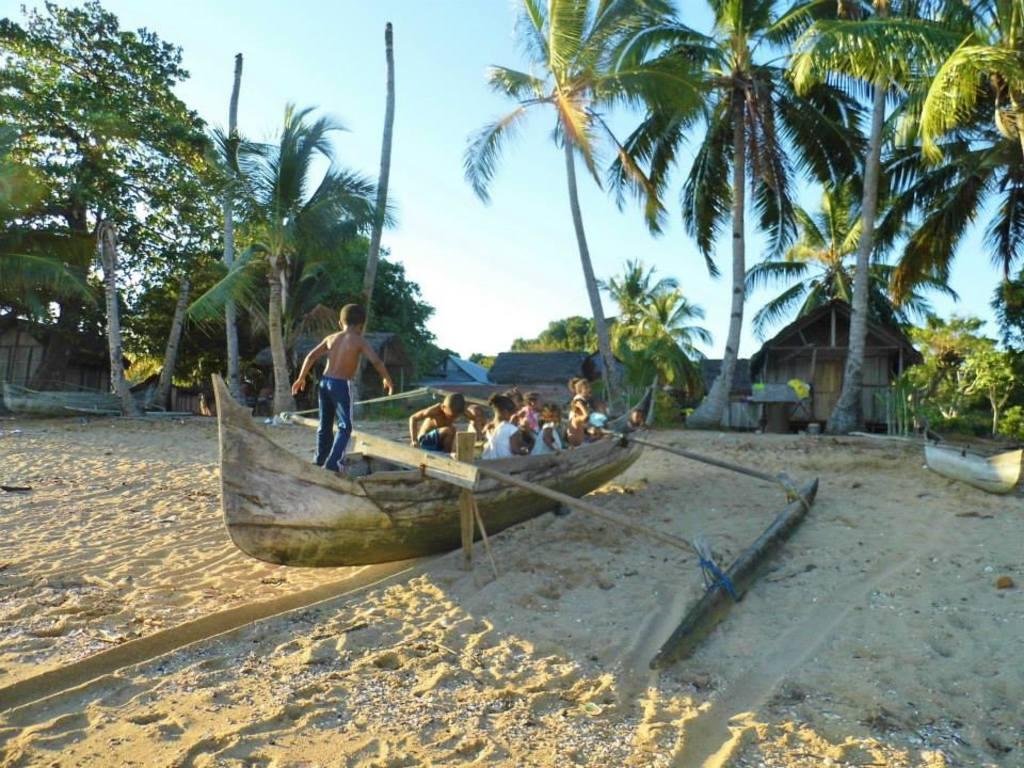Please provide a concise description of this image. In this image I can see few boards on the ground and in the centre of this image I can see number of children on a boat. In the background I can see few buildings, few trees and the sky. 